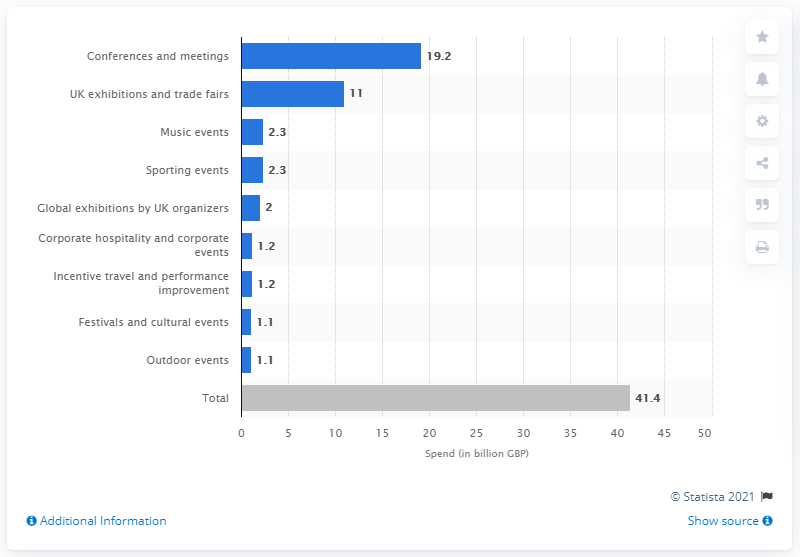How many British pounds were spent on conferences and meetings in 2017?
 19.2 